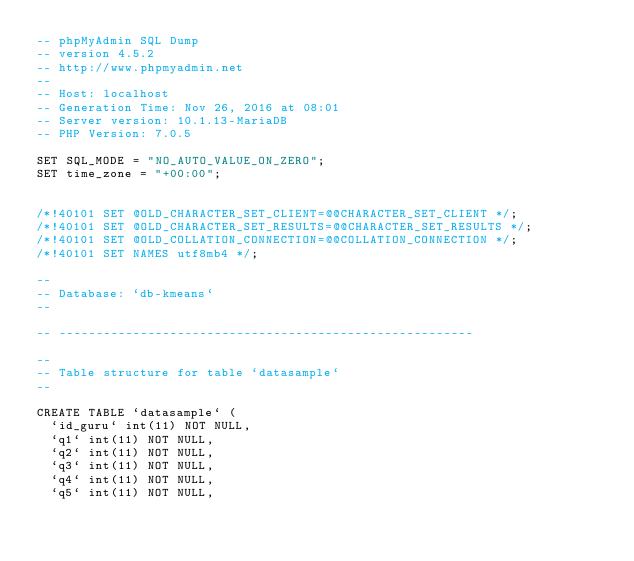Convert code to text. <code><loc_0><loc_0><loc_500><loc_500><_SQL_>-- phpMyAdmin SQL Dump
-- version 4.5.2
-- http://www.phpmyadmin.net
--
-- Host: localhost
-- Generation Time: Nov 26, 2016 at 08:01 
-- Server version: 10.1.13-MariaDB
-- PHP Version: 7.0.5

SET SQL_MODE = "NO_AUTO_VALUE_ON_ZERO";
SET time_zone = "+00:00";


/*!40101 SET @OLD_CHARACTER_SET_CLIENT=@@CHARACTER_SET_CLIENT */;
/*!40101 SET @OLD_CHARACTER_SET_RESULTS=@@CHARACTER_SET_RESULTS */;
/*!40101 SET @OLD_COLLATION_CONNECTION=@@COLLATION_CONNECTION */;
/*!40101 SET NAMES utf8mb4 */;

--
-- Database: `db-kmeans`
--

-- --------------------------------------------------------

--
-- Table structure for table `datasample`
--

CREATE TABLE `datasample` (
  `id_guru` int(11) NOT NULL,
  `q1` int(11) NOT NULL,
  `q2` int(11) NOT NULL,
  `q3` int(11) NOT NULL,
  `q4` int(11) NOT NULL,
  `q5` int(11) NOT NULL,</code> 